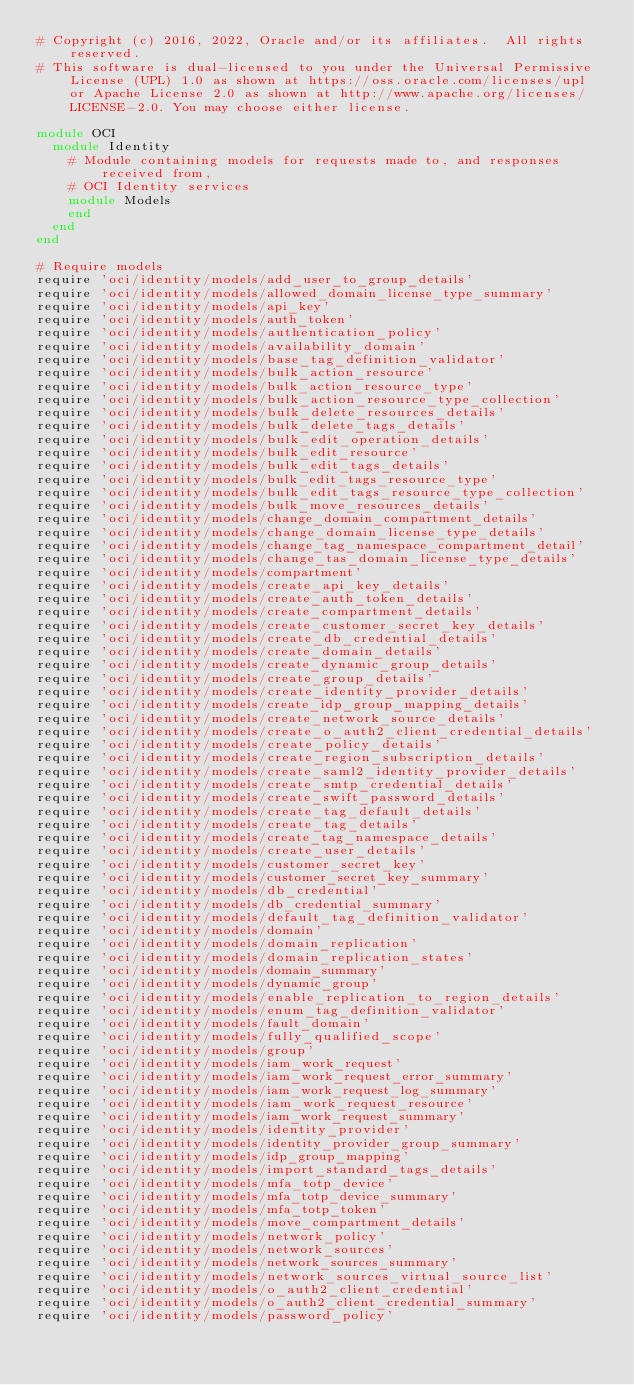Convert code to text. <code><loc_0><loc_0><loc_500><loc_500><_Ruby_># Copyright (c) 2016, 2022, Oracle and/or its affiliates.  All rights reserved.
# This software is dual-licensed to you under the Universal Permissive License (UPL) 1.0 as shown at https://oss.oracle.com/licenses/upl or Apache License 2.0 as shown at http://www.apache.org/licenses/LICENSE-2.0. You may choose either license.

module OCI
  module Identity
    # Module containing models for requests made to, and responses received from,
    # OCI Identity services
    module Models
    end
  end
end

# Require models
require 'oci/identity/models/add_user_to_group_details'
require 'oci/identity/models/allowed_domain_license_type_summary'
require 'oci/identity/models/api_key'
require 'oci/identity/models/auth_token'
require 'oci/identity/models/authentication_policy'
require 'oci/identity/models/availability_domain'
require 'oci/identity/models/base_tag_definition_validator'
require 'oci/identity/models/bulk_action_resource'
require 'oci/identity/models/bulk_action_resource_type'
require 'oci/identity/models/bulk_action_resource_type_collection'
require 'oci/identity/models/bulk_delete_resources_details'
require 'oci/identity/models/bulk_delete_tags_details'
require 'oci/identity/models/bulk_edit_operation_details'
require 'oci/identity/models/bulk_edit_resource'
require 'oci/identity/models/bulk_edit_tags_details'
require 'oci/identity/models/bulk_edit_tags_resource_type'
require 'oci/identity/models/bulk_edit_tags_resource_type_collection'
require 'oci/identity/models/bulk_move_resources_details'
require 'oci/identity/models/change_domain_compartment_details'
require 'oci/identity/models/change_domain_license_type_details'
require 'oci/identity/models/change_tag_namespace_compartment_detail'
require 'oci/identity/models/change_tas_domain_license_type_details'
require 'oci/identity/models/compartment'
require 'oci/identity/models/create_api_key_details'
require 'oci/identity/models/create_auth_token_details'
require 'oci/identity/models/create_compartment_details'
require 'oci/identity/models/create_customer_secret_key_details'
require 'oci/identity/models/create_db_credential_details'
require 'oci/identity/models/create_domain_details'
require 'oci/identity/models/create_dynamic_group_details'
require 'oci/identity/models/create_group_details'
require 'oci/identity/models/create_identity_provider_details'
require 'oci/identity/models/create_idp_group_mapping_details'
require 'oci/identity/models/create_network_source_details'
require 'oci/identity/models/create_o_auth2_client_credential_details'
require 'oci/identity/models/create_policy_details'
require 'oci/identity/models/create_region_subscription_details'
require 'oci/identity/models/create_saml2_identity_provider_details'
require 'oci/identity/models/create_smtp_credential_details'
require 'oci/identity/models/create_swift_password_details'
require 'oci/identity/models/create_tag_default_details'
require 'oci/identity/models/create_tag_details'
require 'oci/identity/models/create_tag_namespace_details'
require 'oci/identity/models/create_user_details'
require 'oci/identity/models/customer_secret_key'
require 'oci/identity/models/customer_secret_key_summary'
require 'oci/identity/models/db_credential'
require 'oci/identity/models/db_credential_summary'
require 'oci/identity/models/default_tag_definition_validator'
require 'oci/identity/models/domain'
require 'oci/identity/models/domain_replication'
require 'oci/identity/models/domain_replication_states'
require 'oci/identity/models/domain_summary'
require 'oci/identity/models/dynamic_group'
require 'oci/identity/models/enable_replication_to_region_details'
require 'oci/identity/models/enum_tag_definition_validator'
require 'oci/identity/models/fault_domain'
require 'oci/identity/models/fully_qualified_scope'
require 'oci/identity/models/group'
require 'oci/identity/models/iam_work_request'
require 'oci/identity/models/iam_work_request_error_summary'
require 'oci/identity/models/iam_work_request_log_summary'
require 'oci/identity/models/iam_work_request_resource'
require 'oci/identity/models/iam_work_request_summary'
require 'oci/identity/models/identity_provider'
require 'oci/identity/models/identity_provider_group_summary'
require 'oci/identity/models/idp_group_mapping'
require 'oci/identity/models/import_standard_tags_details'
require 'oci/identity/models/mfa_totp_device'
require 'oci/identity/models/mfa_totp_device_summary'
require 'oci/identity/models/mfa_totp_token'
require 'oci/identity/models/move_compartment_details'
require 'oci/identity/models/network_policy'
require 'oci/identity/models/network_sources'
require 'oci/identity/models/network_sources_summary'
require 'oci/identity/models/network_sources_virtual_source_list'
require 'oci/identity/models/o_auth2_client_credential'
require 'oci/identity/models/o_auth2_client_credential_summary'
require 'oci/identity/models/password_policy'</code> 